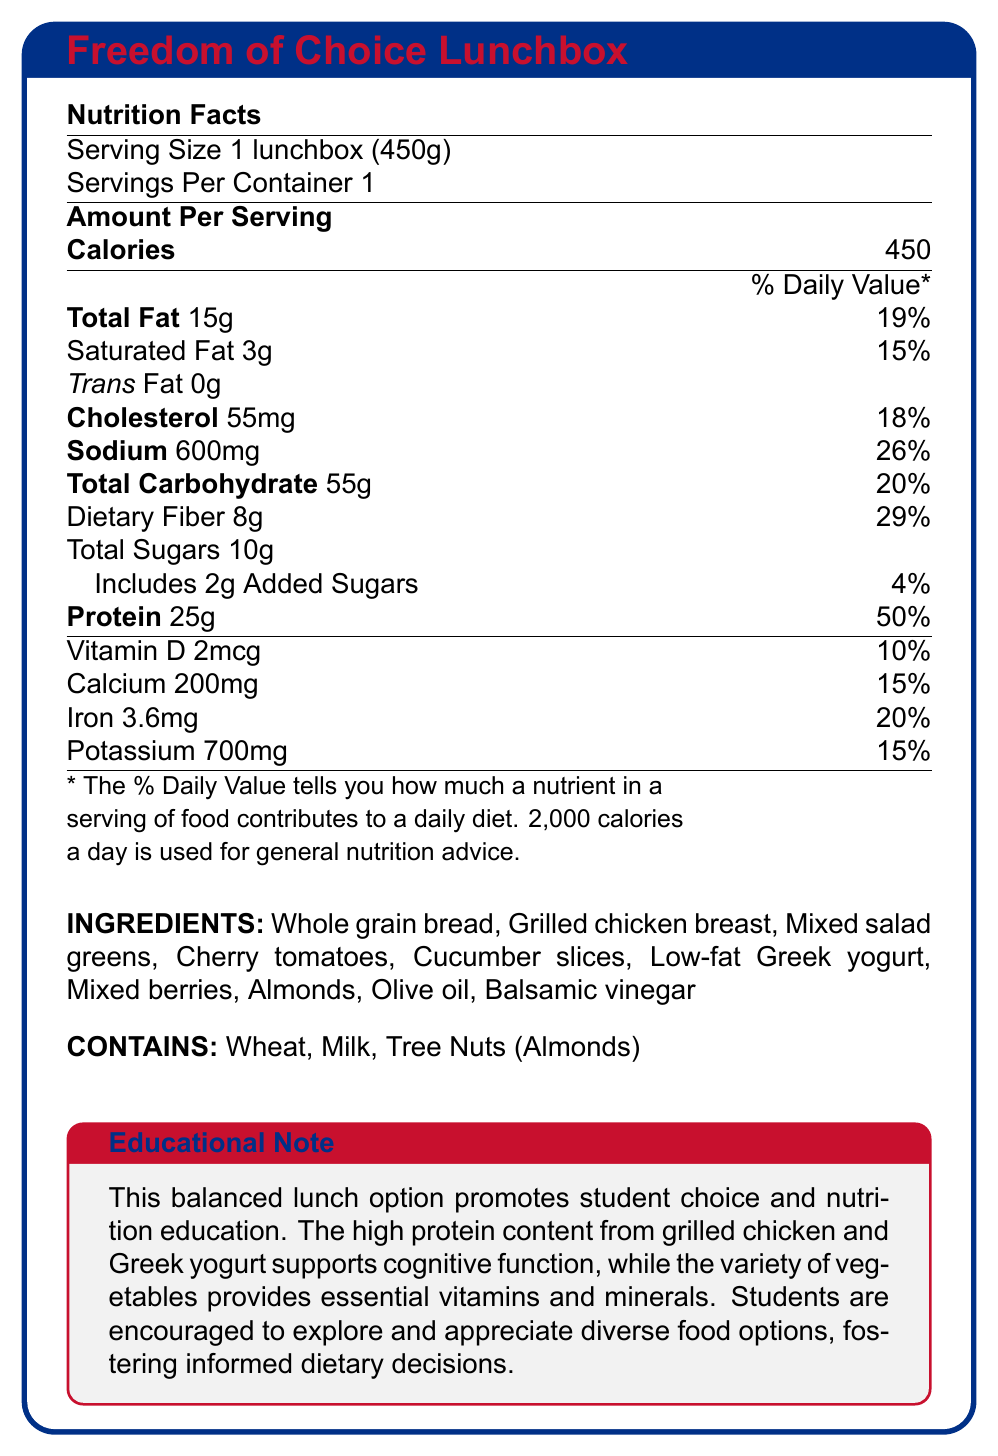How many calories are in one serving of the Freedom of Choice Lunchbox? The document states that there are 450 calories per serving.
Answer: 450 What is the serving size of the Freedom of Choice Lunchbox? The serving size listed is 1 lunchbox, which weighs 450 grams.
Answer: 1 lunchbox (450g) How much protein does the Freedom of Choice Lunchbox contain? The document specifies that the lunchbox contains 25 grams of protein.
Answer: 25g What percentage of the daily value of dietary fiber does the Freedom of Choice Lunchbox provide? The document indicates that the dietary fiber content is 29% of the daily value.
Answer: 29% List the main protein sources in the Freedom of Choice Lunchbox. These are the ingredients listed in the document that are known for their high protein content.
Answer: Grilled chicken breast, Low-fat Greek yogurt, and Almonds What is the total fat content in the Freedom of Choice Lunchbox? A. 10g B. 15g C. 20g D. 25g The document states that the total fat content is 15 grams.
Answer: B. 15g Which of the following allergens are present in the Freedom of Choice Lunchbox? (Select all that apply) A. Wheat B. Peanuts C. Milk D. Tree Nuts (Almonds) The document lists wheat, milk, and tree nuts (almonds) as allergens.
Answer: A, C, D Does the Freedom of Choice Lunchbox contain trans fat? The document states that the lunchbox contains 0 grams of trans fat.
Answer: No Describe the main idea of the Freedom of Choice Lunchbox document. The document provides detailed nutritional information and highlights the educational benefits of the lunchbox, encouraging students to explore and appreciate diverse food options.
Answer: The document outlines the nutritional information of the Freedom of Choice Lunchbox, highlighting its balanced content of protein and vegetables. It promotes student choice and nutrition education, emphasizing protein sources like grilled chicken and Greek yogurt, and a variety of vegetables for essential vitamins and minerals. What is the main benefit of the high protein content mentioned in the educational note? The educational note specifically mentions that the high protein content helps support cognitive function.
Answer: Supports cognitive function How much sodium is in one serving of the Freedom of Choice Lunchbox? The document specifies that one serving contains 600 milligrams of sodium.
Answer: 600mg What are the vegetables included in the Freedom of Choice Lunchbox? These are the vegetables listed in the ingredients section.
Answer: Mixed salad greens, Cherry tomatoes, Cucumber slices Does the Freedom of Choice Lunchbox provide any calcium? The document states that the lunchbox contains 200mg of calcium, which is 15% of the daily value.
Answer: Yes What is the percent daily value of cholesterol in the Freedom of Choice Lunchbox? The document lists the cholesterol amount as 55mg, which is 18% of the daily value.
Answer: 18% What is the total amount of sugars, including added sugars, in the Freedom of Choice Lunchbox? The document states that the total sugars amount to 10 grams, which includes 2 grams of added sugars.
Answer: 10g total, with 2g being added sugars Are there any peanuts in the Freedom of Choice Lunchbox? There is no mention of peanuts in the ingredients or allergen information.
Answer: No What are the two main sources of protein in the Freedom of Choice Lunchbox? The document lists these two ingredients which are known high-protein food items.
Answer: Grilled chicken breast, Low-fat Greek yogurt Based on the document, what is the emphasis of the Freedom of Choice Lunchbox? The educational note emphasizes the importance of student choice in nutrition and the benefits of a balanced diet.
Answer: Promotes student choice and nutrition education by offering a balanced meal with high protein content and a variety of vegetables. What is the percent daily value of Vitamin D in the Freedom of Choice Lunchbox? The document states that one serving of the lunchbox contains 2mcg of Vitamin D, which is 10% of the daily value.
Answer: 10% What is the daily value percentage of iron provided by the Freedom of Choice Lunchbox? The nutritional information states that the lunchbox provides 3.6mg of iron, which is 20% of the daily value.
Answer: 20% How many servings are in each Freedom of Choice Lunchbox? The document specifies that there is 1 serving per container.
Answer: 1 What type of dietary decision does the document encourage students to make? The educational note mentions that students are encouraged to make informed dietary decisions by exploring and appreciating diverse food options.
Answer: Informed dietary decisions Which ingredient in the Freedom of Choice Lunchbox might someone with a tree nut allergy need to avoid? The document explicitly lists almonds, which are a type of tree nut, in the ingredients and allergen information.
Answer: Almonds 